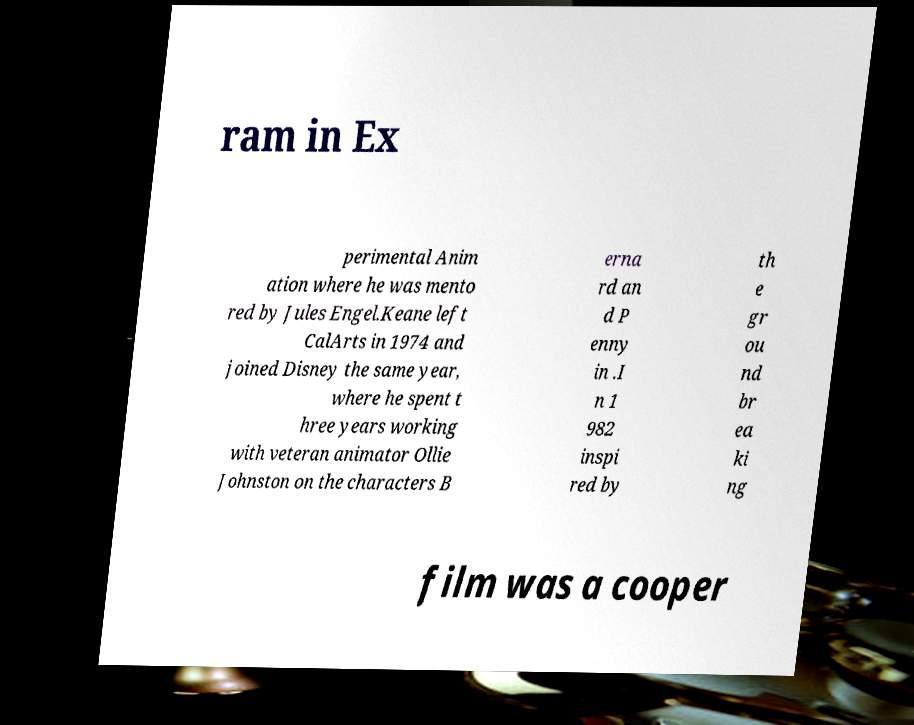There's text embedded in this image that I need extracted. Can you transcribe it verbatim? ram in Ex perimental Anim ation where he was mento red by Jules Engel.Keane left CalArts in 1974 and joined Disney the same year, where he spent t hree years working with veteran animator Ollie Johnston on the characters B erna rd an d P enny in .I n 1 982 inspi red by th e gr ou nd br ea ki ng film was a cooper 